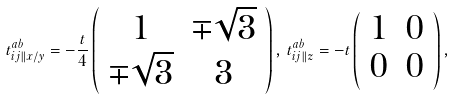<formula> <loc_0><loc_0><loc_500><loc_500>t _ { { i j } \| x / y } ^ { a b } = - \frac { t } { 4 } \left ( \begin{array} { c c } 1 & \mp \sqrt { 3 } \\ \mp \sqrt { 3 } & 3 \\ \end{array} \right ) , \, t _ { { i j } \| z } ^ { a b } = - t \left ( \begin{array} { c c } 1 & 0 \\ 0 & 0 \\ \end{array} \right ) ,</formula> 